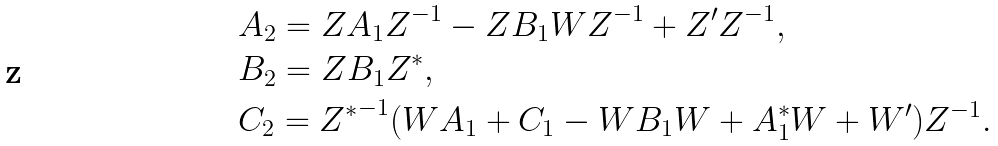<formula> <loc_0><loc_0><loc_500><loc_500>& A _ { 2 } = Z A _ { 1 } Z ^ { - 1 } - Z B _ { 1 } W Z ^ { - 1 } + Z ^ { \prime } Z ^ { - 1 } , \\ & B _ { 2 } = Z B _ { 1 } Z ^ { * } , \\ & C _ { 2 } = { Z ^ { * } } ^ { - 1 } ( W A _ { 1 } + C _ { 1 } - W B _ { 1 } W + A _ { 1 } ^ { * } W + W ^ { \prime } ) Z ^ { - 1 } .</formula> 